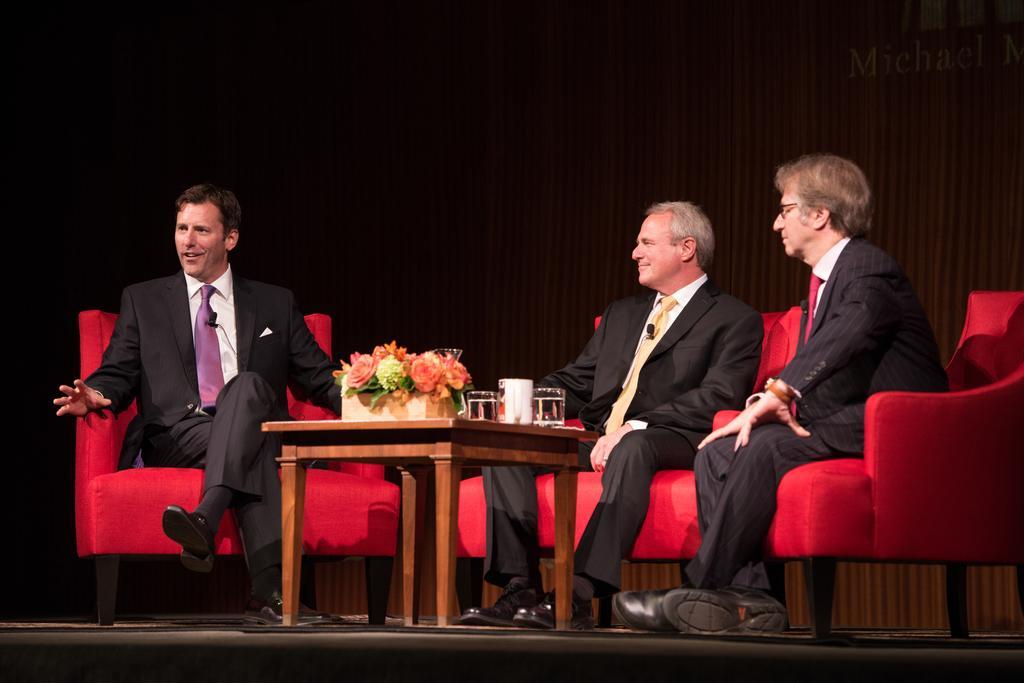Could you give a brief overview of what you see in this image? Here we can see three men sitting on the chairs. This is a table. On the table there is a flower vase and glasses. In the background there is a curtain. 